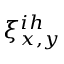Convert formula to latex. <formula><loc_0><loc_0><loc_500><loc_500>\xi _ { x , y } ^ { i h }</formula> 